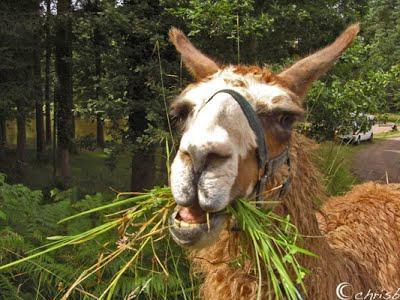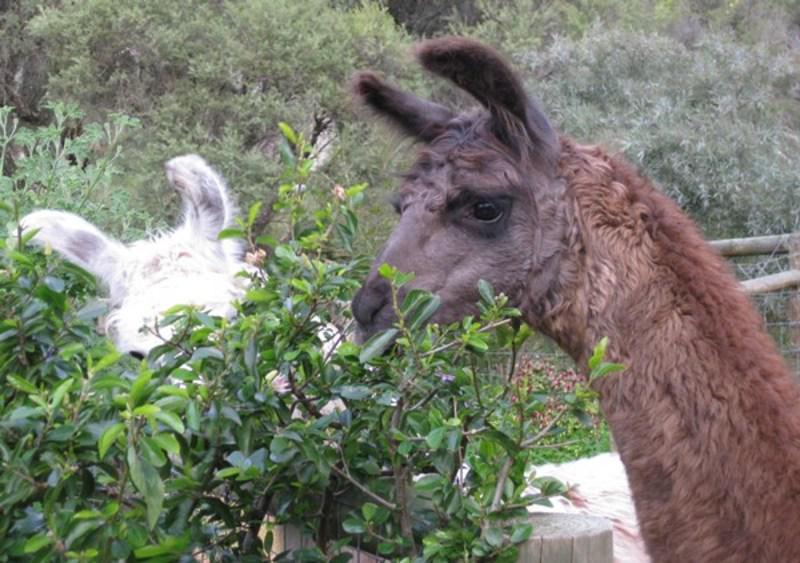The first image is the image on the left, the second image is the image on the right. Examine the images to the left and right. Is the description "A human is feeding one of the llamas" accurate? Answer yes or no. No. The first image is the image on the left, the second image is the image on the right. Examine the images to the left and right. Is the description "In at least one image there is a long necked animal facing forward left with greenery in its mouth." accurate? Answer yes or no. Yes. 